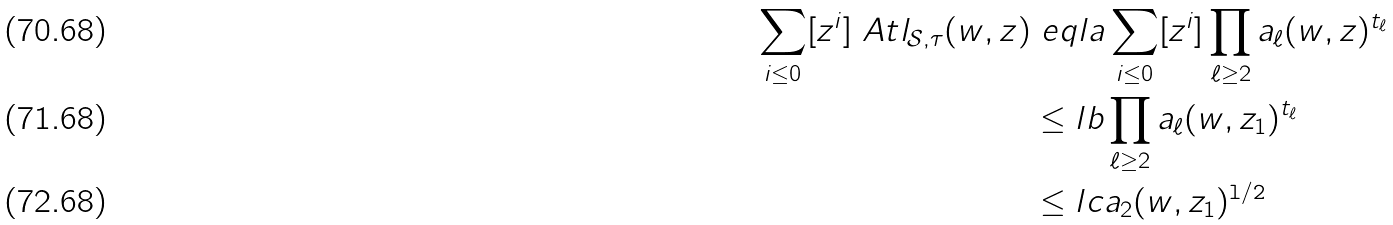Convert formula to latex. <formula><loc_0><loc_0><loc_500><loc_500>\sum _ { i \leq 0 } [ z ^ { i } ] \ A t l _ { \mathcal { S } , \tau } ( w , z ) & \ e q l { a } \sum _ { i \leq 0 } [ z ^ { i } ] \prod _ { \ell \geq 2 } a _ { \ell } ( w , z ) ^ { t _ { \ell } } \\ & \leq l { b } \prod _ { \ell \geq 2 } a _ { \ell } ( w , z _ { 1 } ) ^ { t _ { \ell } } \\ & \leq l { c } a _ { 2 } ( w , z _ { 1 } ) ^ { \tt l / 2 }</formula> 